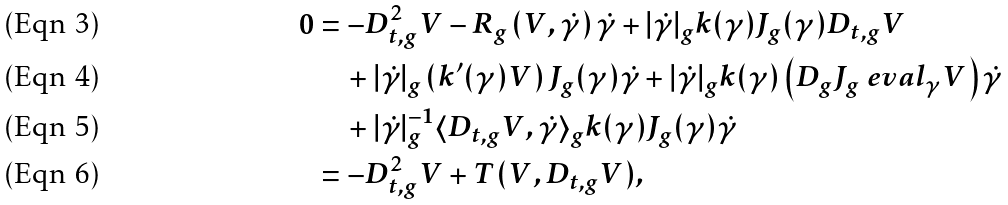Convert formula to latex. <formula><loc_0><loc_0><loc_500><loc_500>0 & = - D _ { t , g } ^ { 2 } V - R _ { g } \left ( V , \dot { \gamma } \right ) \dot { \gamma } + | \dot { \gamma } | _ { g } k ( \gamma ) J _ { g } ( \gamma ) D _ { t , g } V \\ & \quad + | \dot { \gamma } | _ { g } \left ( k ^ { \prime } ( \gamma ) V \right ) J _ { g } ( \gamma ) \dot { \gamma } + | \dot { \gamma } | _ { g } k ( \gamma ) \left ( D _ { g } J _ { g } \ e v a l _ { \gamma } V \right ) \dot { \gamma } \\ & \quad + | \dot { \gamma } | _ { g } ^ { - 1 } \langle D _ { t , g } V , \dot { \gamma } \rangle _ { g } k ( \gamma ) J _ { g } ( \gamma ) \dot { \gamma } \\ & = - D _ { t , g } ^ { 2 } V + T ( V , D _ { t , g } V ) ,</formula> 